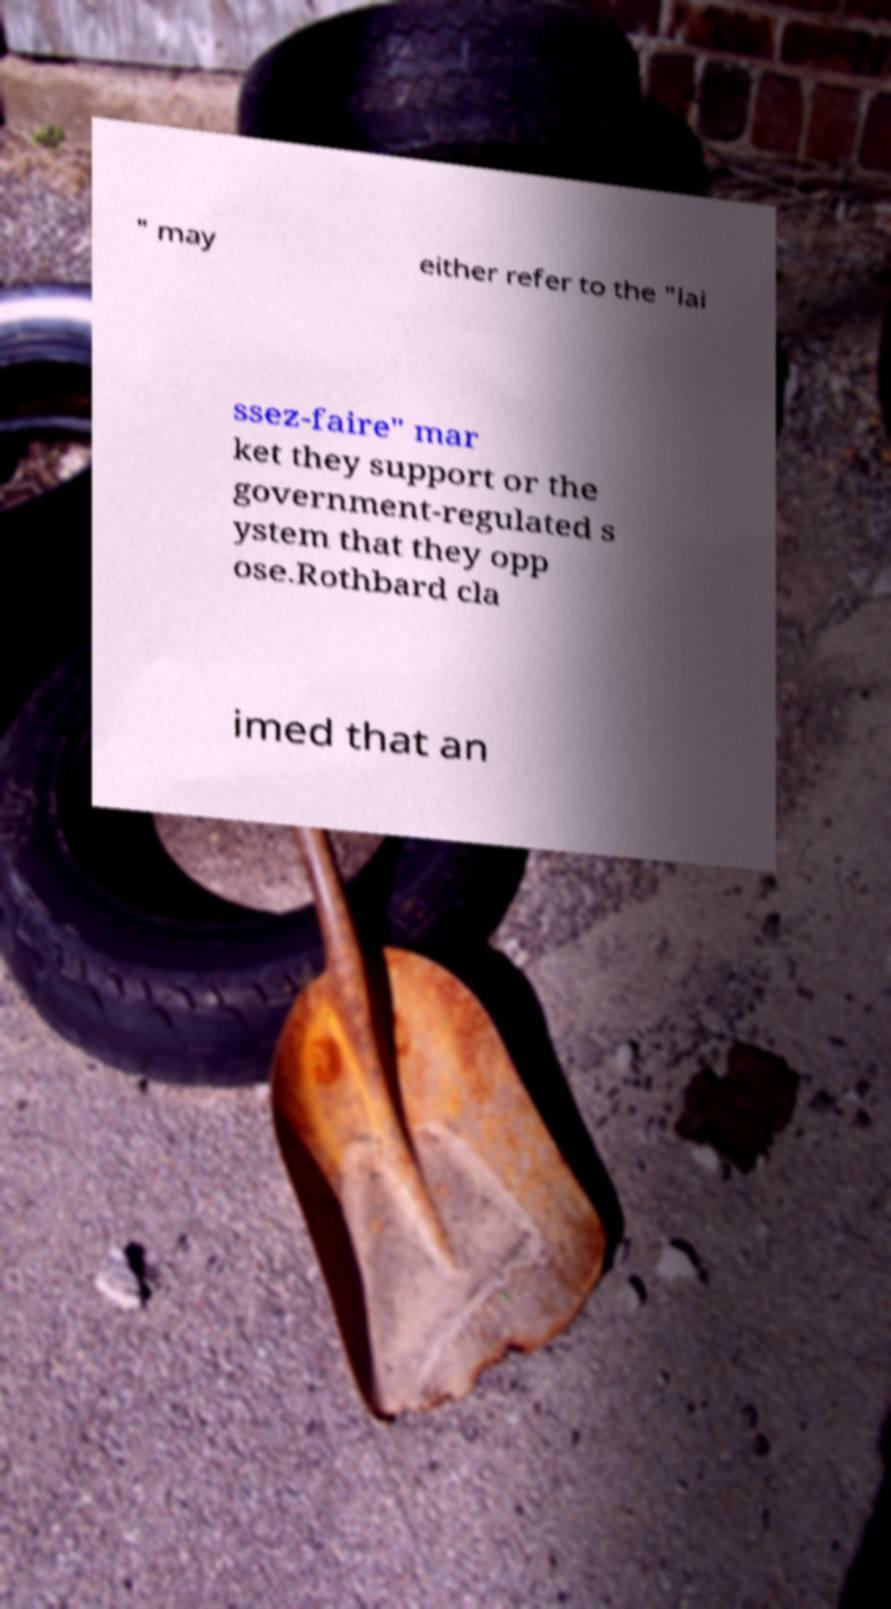What messages or text are displayed in this image? I need them in a readable, typed format. " may either refer to the "lai ssez-faire" mar ket they support or the government-regulated s ystem that they opp ose.Rothbard cla imed that an 